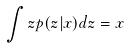Convert formula to latex. <formula><loc_0><loc_0><loc_500><loc_500>\int z p ( z | x ) d z = x</formula> 